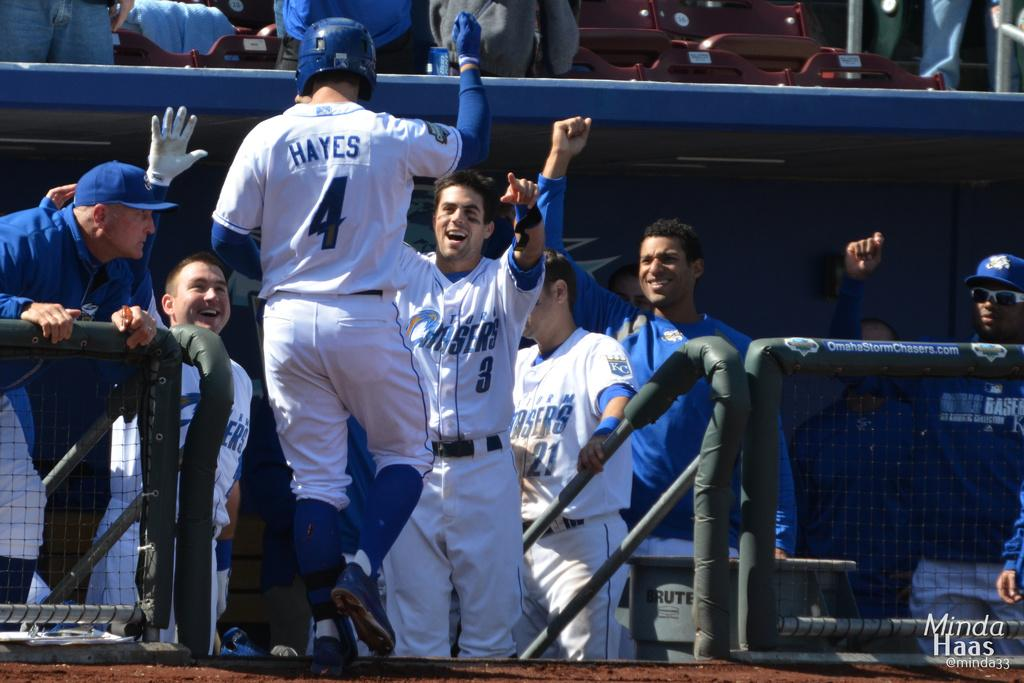<image>
Present a compact description of the photo's key features. A player named Hayes is welcomed into the dugout by happy teammates. 